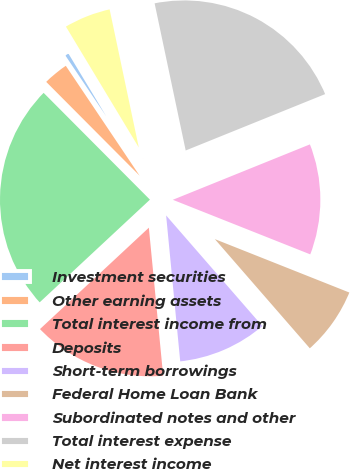Convert chart. <chart><loc_0><loc_0><loc_500><loc_500><pie_chart><fcel>Investment securities<fcel>Other earning assets<fcel>Total interest income from<fcel>Deposits<fcel>Short-term borrowings<fcel>Federal Home Loan Bank<fcel>Subordinated notes and other<fcel>Total interest expense<fcel>Net interest income<nl><fcel>0.78%<fcel>3.05%<fcel>24.47%<fcel>14.6%<fcel>9.86%<fcel>7.59%<fcel>12.13%<fcel>22.2%<fcel>5.32%<nl></chart> 